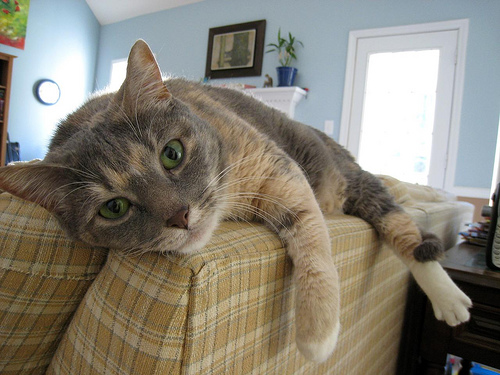What is the cat doing in the picture? The cat is lying down on the armrest of a sofa, with its front paws hanging down and its gaze directed towards the camera, giving off a sense of contentment and ease. 